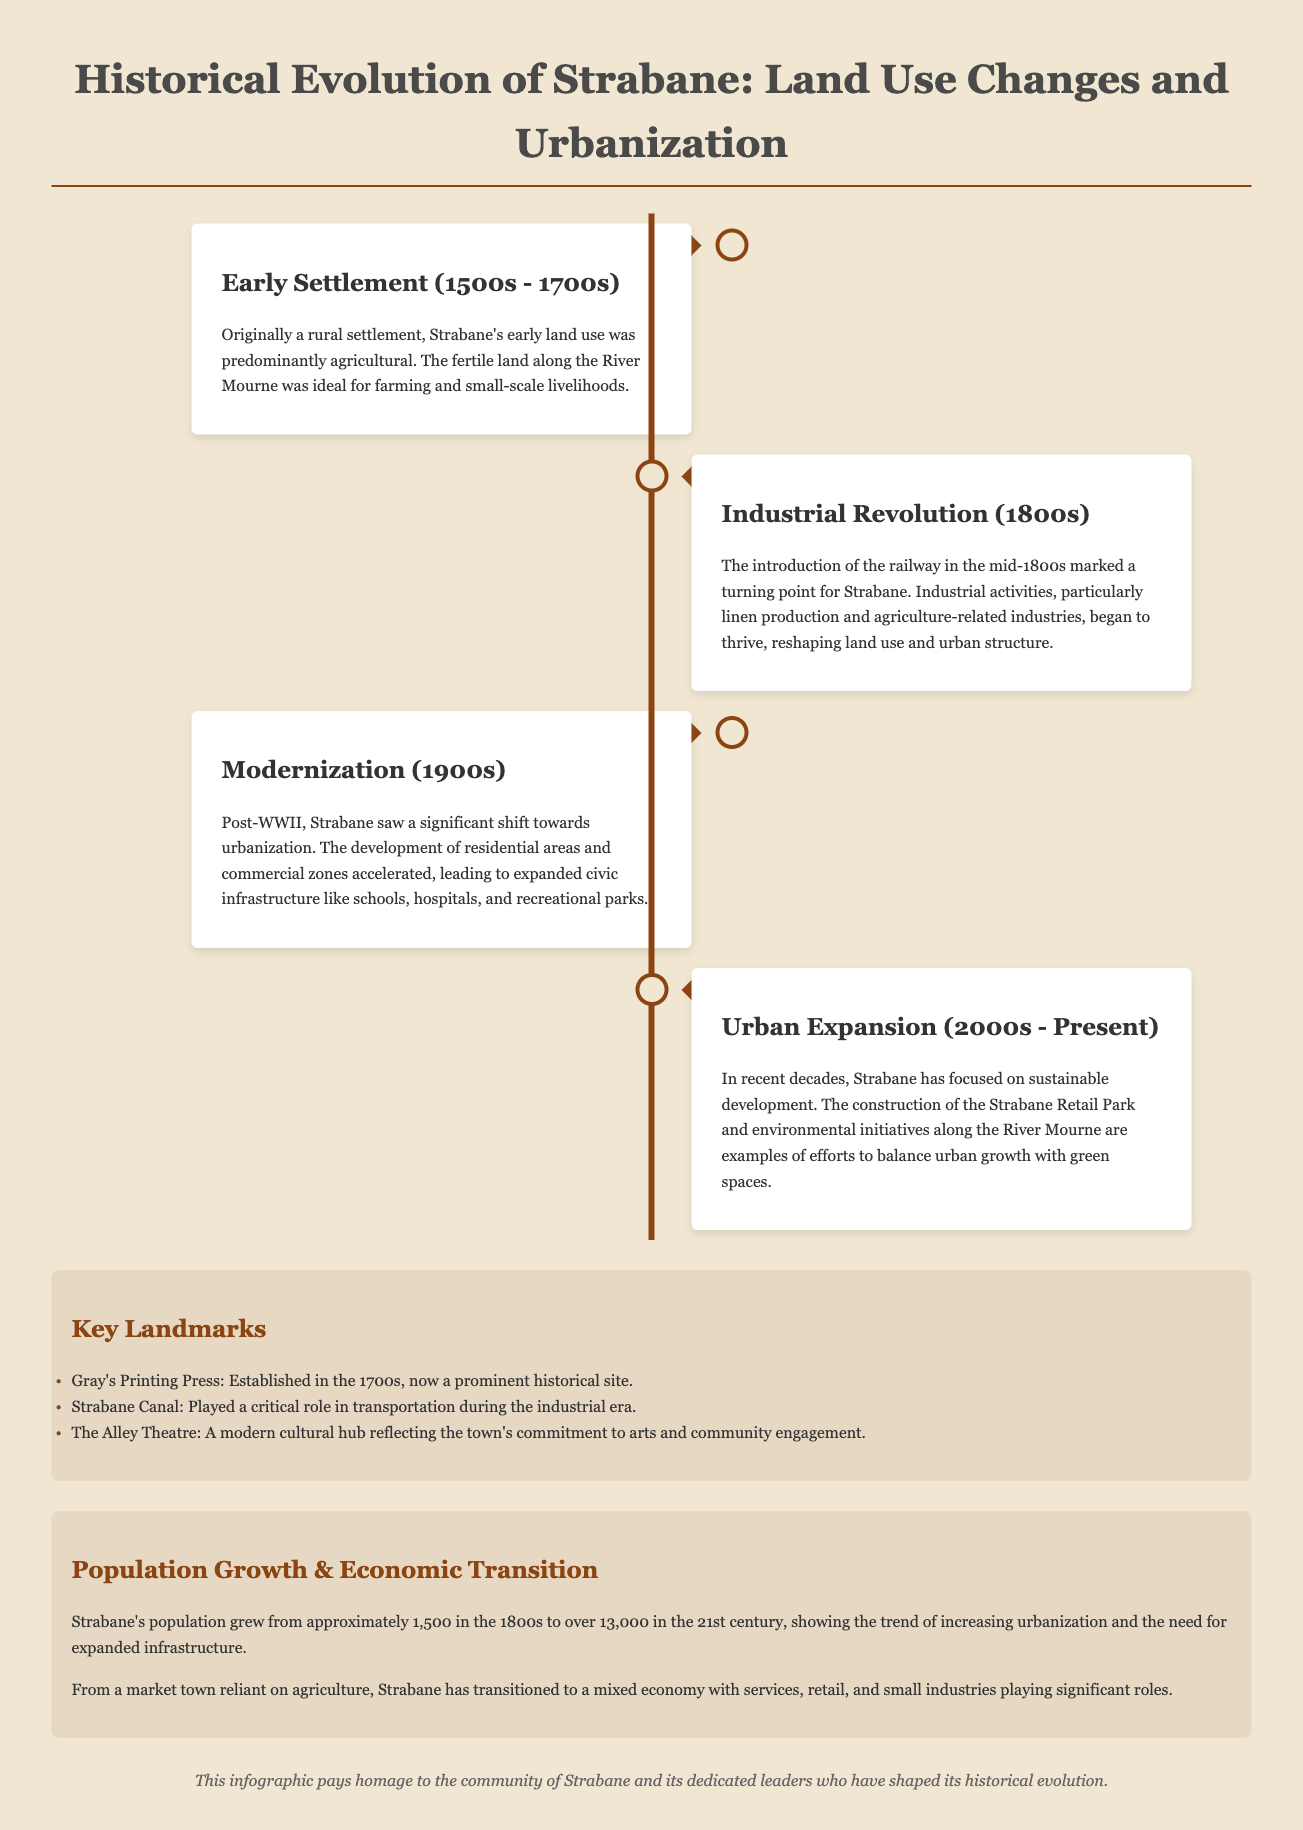what was the primary land use in early Strabane? Early land use in Strabane was predominantly agricultural, supporting small-scale livelihoods.
Answer: agricultural which revolution significantly changed Strabane's land use? The introduction of the railway during the Industrial Revolution reshaped land use in Strabane.
Answer: Industrial Revolution what decade marked a shift towards urbanization in Strabane? Post-WWII, particularly during the 1900s, Strabane saw a significant shift towards urbanization.
Answer: 1900s how many people lived in Strabane in the 1800s? The population of Strabane in the 1800s was approximately 1,500.
Answer: 1,500 what is a key landmark established in the 1700s in Strabane? Gray's Printing Press, established in the 1700s, is a prominent historical site in Strabane.
Answer: Gray's Printing Press which initiative reflects Strabane's focus on sustainability? The construction of the Strabane Retail Park is an example of sustainability efforts in recent decades.
Answer: Strabane Retail Park what was Strabane's population in the 21st century? Strabane's population grew to over 13,000 in the 21st century.
Answer: over 13,000 what role did the Strabane Canal play during the industrial era? The Strabane Canal played a critical role in transportation during the industrial era.
Answer: transportation name a modern cultural hub in Strabane. The Alley Theatre is recognized as a modern cultural hub in Strabane.
Answer: The Alley Theatre 